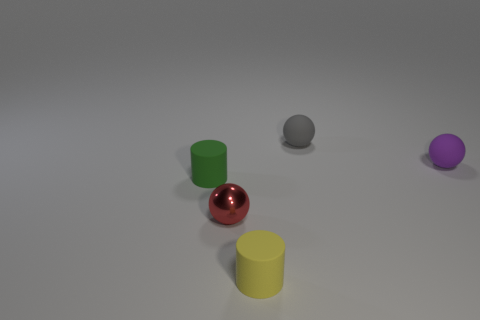Add 3 small yellow metallic spheres. How many objects exist? 8 Subtract all balls. How many objects are left? 2 Add 4 small gray matte objects. How many small gray matte objects exist? 5 Subtract 1 green cylinders. How many objects are left? 4 Subtract all big green rubber spheres. Subtract all gray balls. How many objects are left? 4 Add 5 balls. How many balls are left? 8 